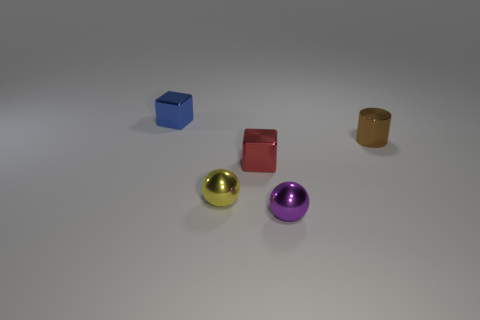Add 3 brown metal cylinders. How many objects exist? 8 Subtract all cylinders. How many objects are left? 4 Add 3 yellow shiny objects. How many yellow shiny objects are left? 4 Add 5 tiny yellow metallic balls. How many tiny yellow metallic balls exist? 6 Subtract 0 yellow cylinders. How many objects are left? 5 Subtract all small gray shiny things. Subtract all blocks. How many objects are left? 3 